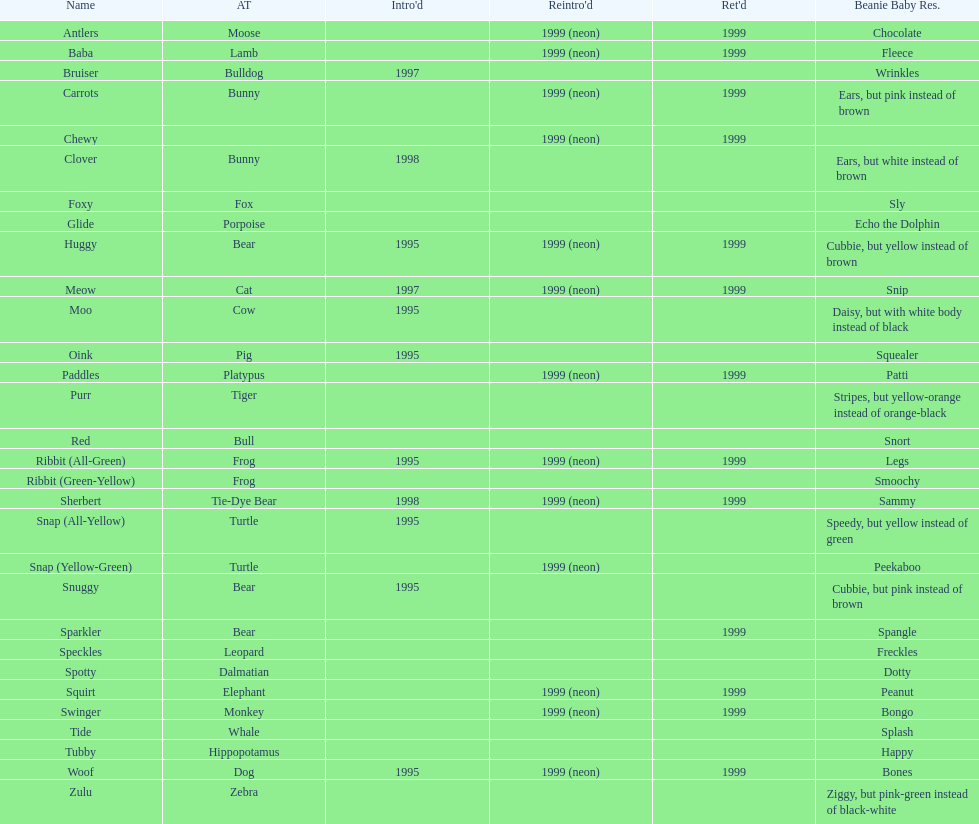How long was woof the dog sold before it was retired? 4 years. 